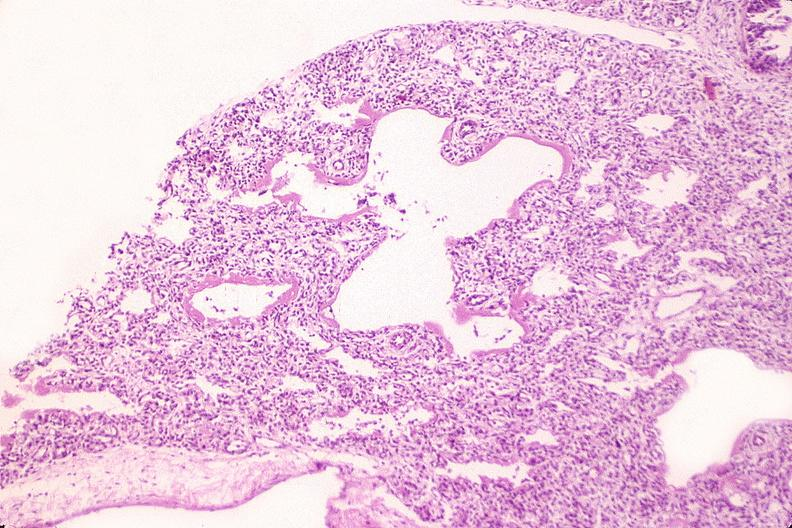does this image show lungs, hyaline membrane disease?
Answer the question using a single word or phrase. Yes 